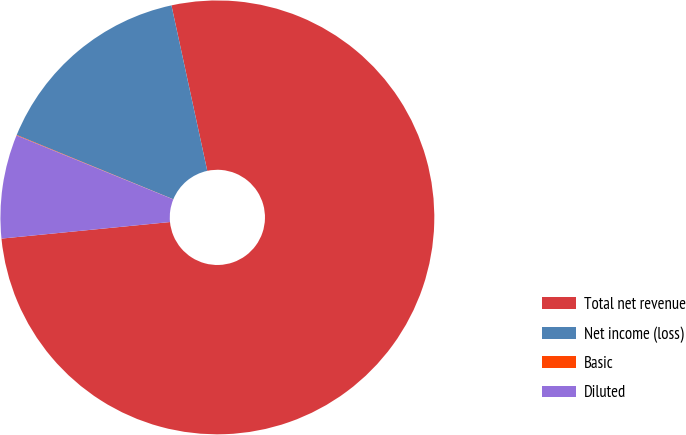Convert chart to OTSL. <chart><loc_0><loc_0><loc_500><loc_500><pie_chart><fcel>Total net revenue<fcel>Net income (loss)<fcel>Basic<fcel>Diluted<nl><fcel>76.83%<fcel>15.4%<fcel>0.04%<fcel>7.72%<nl></chart> 